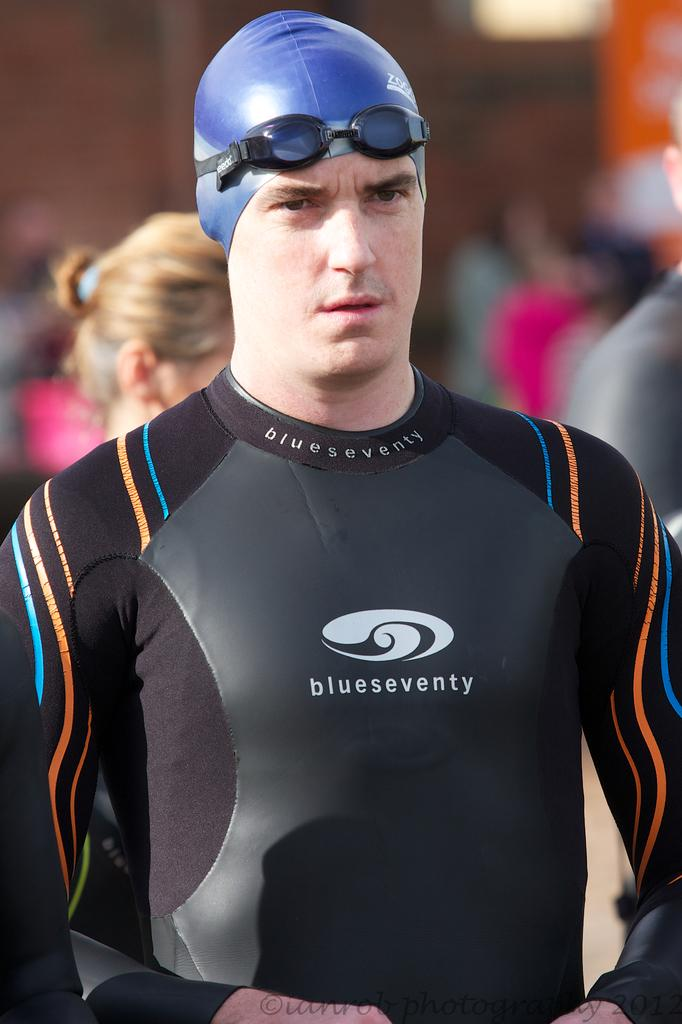What is the main subject of the image? There is a man standing in the image. Are there any other people in the image? Yes, there are people standing behind the man. Can you describe the background of the image? The background of the image is blurred. What type of silk is being advertised in the image? There is no silk or advertisement present in the image; it features a man standing with people behind him in a blurred background. 